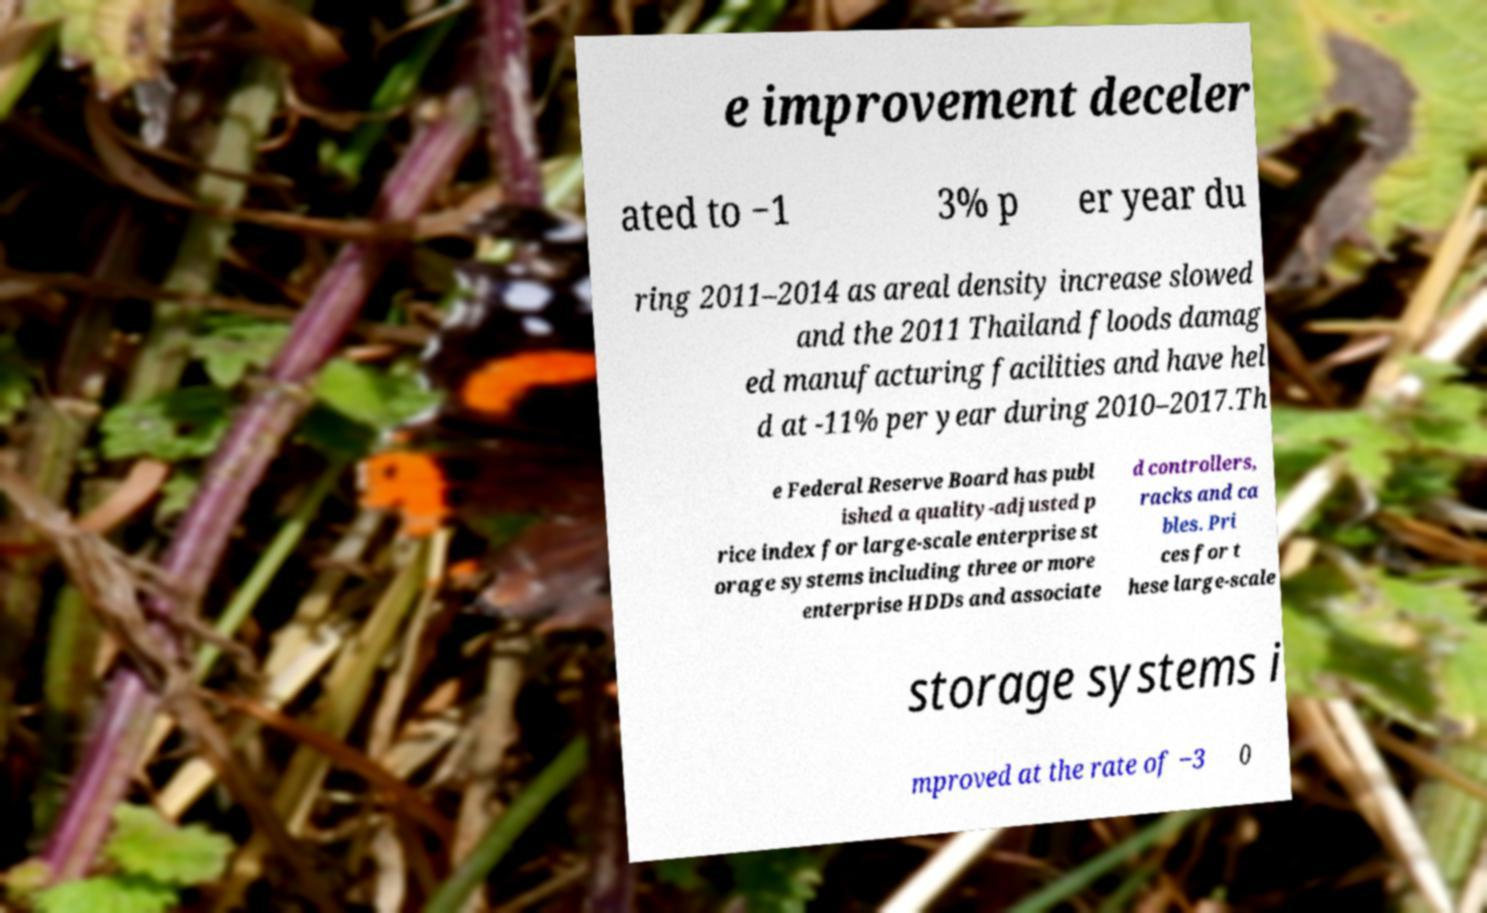For documentation purposes, I need the text within this image transcribed. Could you provide that? e improvement deceler ated to −1 3% p er year du ring 2011–2014 as areal density increase slowed and the 2011 Thailand floods damag ed manufacturing facilities and have hel d at -11% per year during 2010–2017.Th e Federal Reserve Board has publ ished a quality-adjusted p rice index for large-scale enterprise st orage systems including three or more enterprise HDDs and associate d controllers, racks and ca bles. Pri ces for t hese large-scale storage systems i mproved at the rate of ‒3 0 